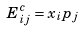<formula> <loc_0><loc_0><loc_500><loc_500>E _ { i j } ^ { c } = x _ { i } p _ { j }</formula> 